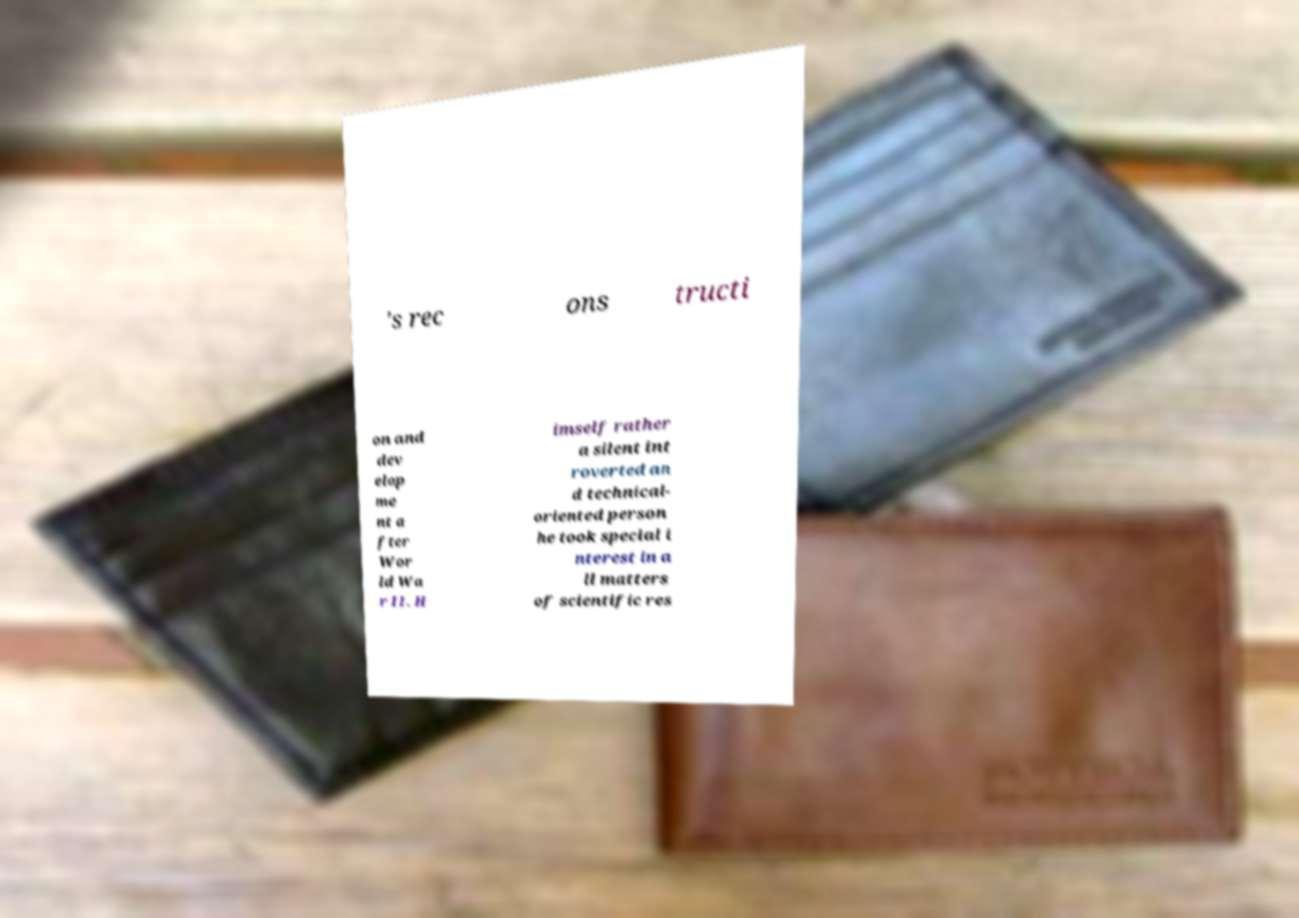Could you extract and type out the text from this image? 's rec ons tructi on and dev elop me nt a fter Wor ld Wa r II. H imself rather a silent int roverted an d technical- oriented person he took special i nterest in a ll matters of scientific res 